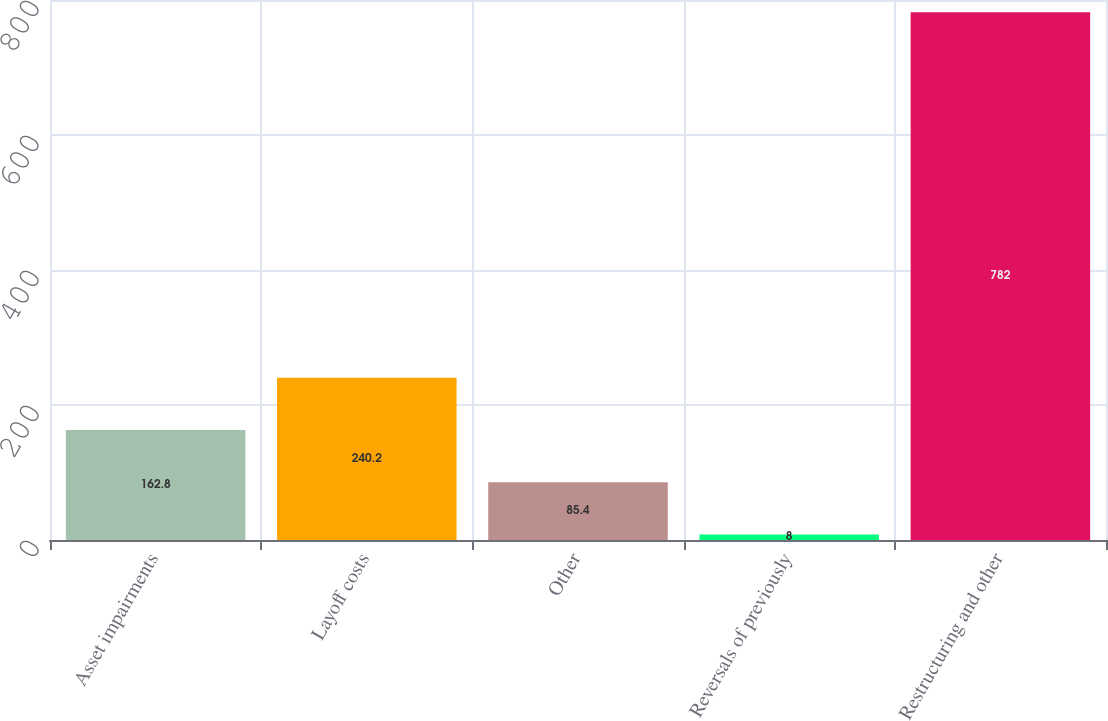<chart> <loc_0><loc_0><loc_500><loc_500><bar_chart><fcel>Asset impairments<fcel>Layoff costs<fcel>Other<fcel>Reversals of previously<fcel>Restructuring and other<nl><fcel>162.8<fcel>240.2<fcel>85.4<fcel>8<fcel>782<nl></chart> 